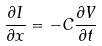Convert formula to latex. <formula><loc_0><loc_0><loc_500><loc_500>\frac { \partial I } { \partial x } = - C \frac { \partial V } { \partial t }</formula> 